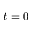Convert formula to latex. <formula><loc_0><loc_0><loc_500><loc_500>t = 0</formula> 